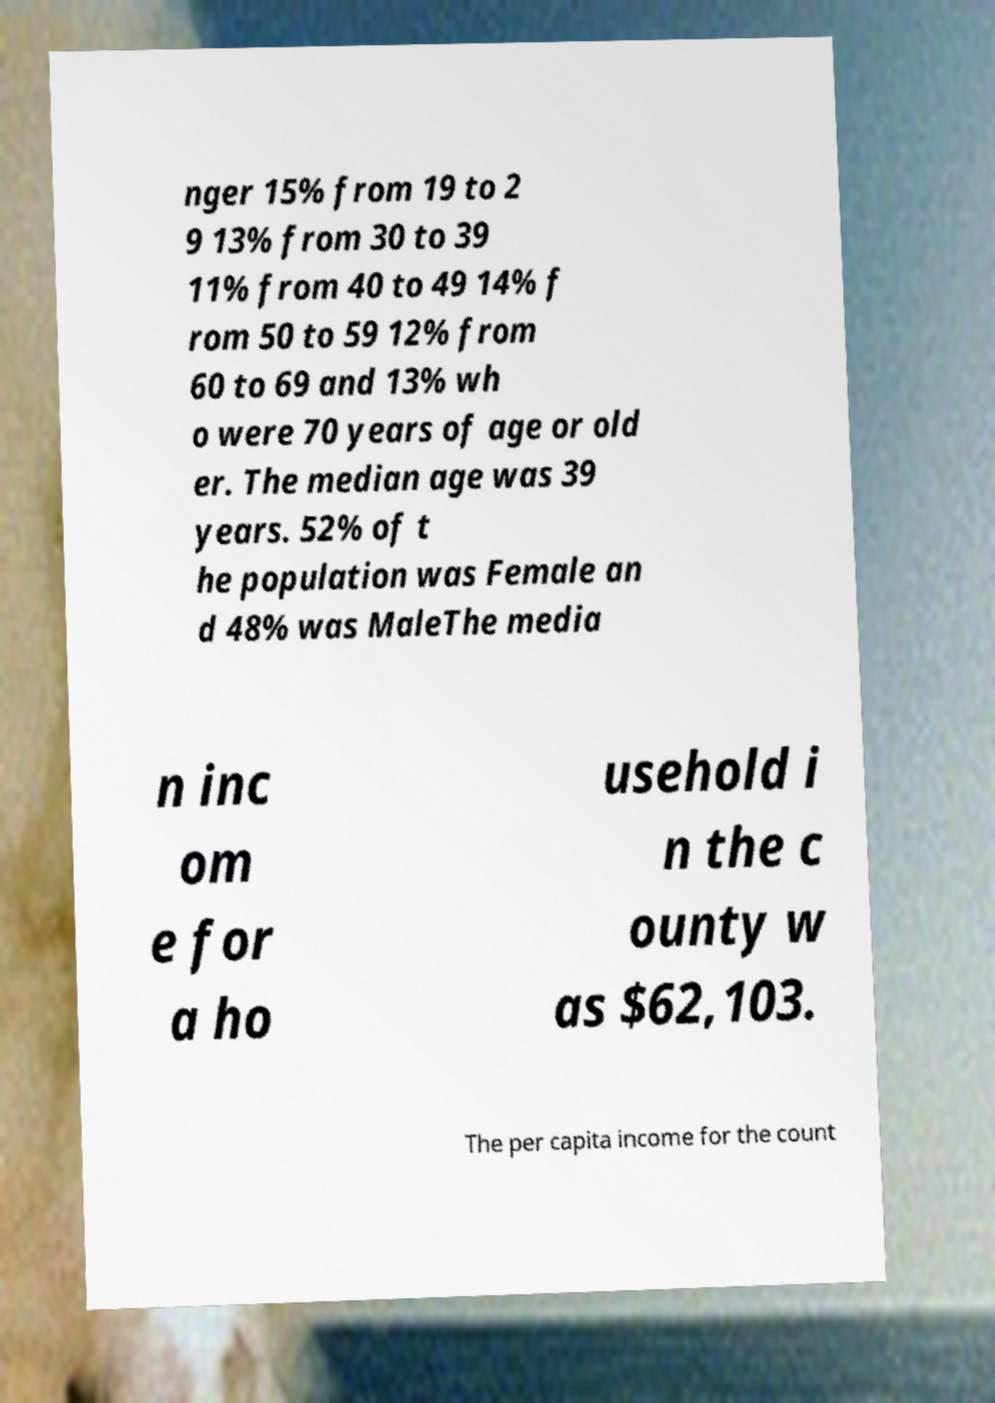There's text embedded in this image that I need extracted. Can you transcribe it verbatim? nger 15% from 19 to 2 9 13% from 30 to 39 11% from 40 to 49 14% f rom 50 to 59 12% from 60 to 69 and 13% wh o were 70 years of age or old er. The median age was 39 years. 52% of t he population was Female an d 48% was MaleThe media n inc om e for a ho usehold i n the c ounty w as $62,103. The per capita income for the count 